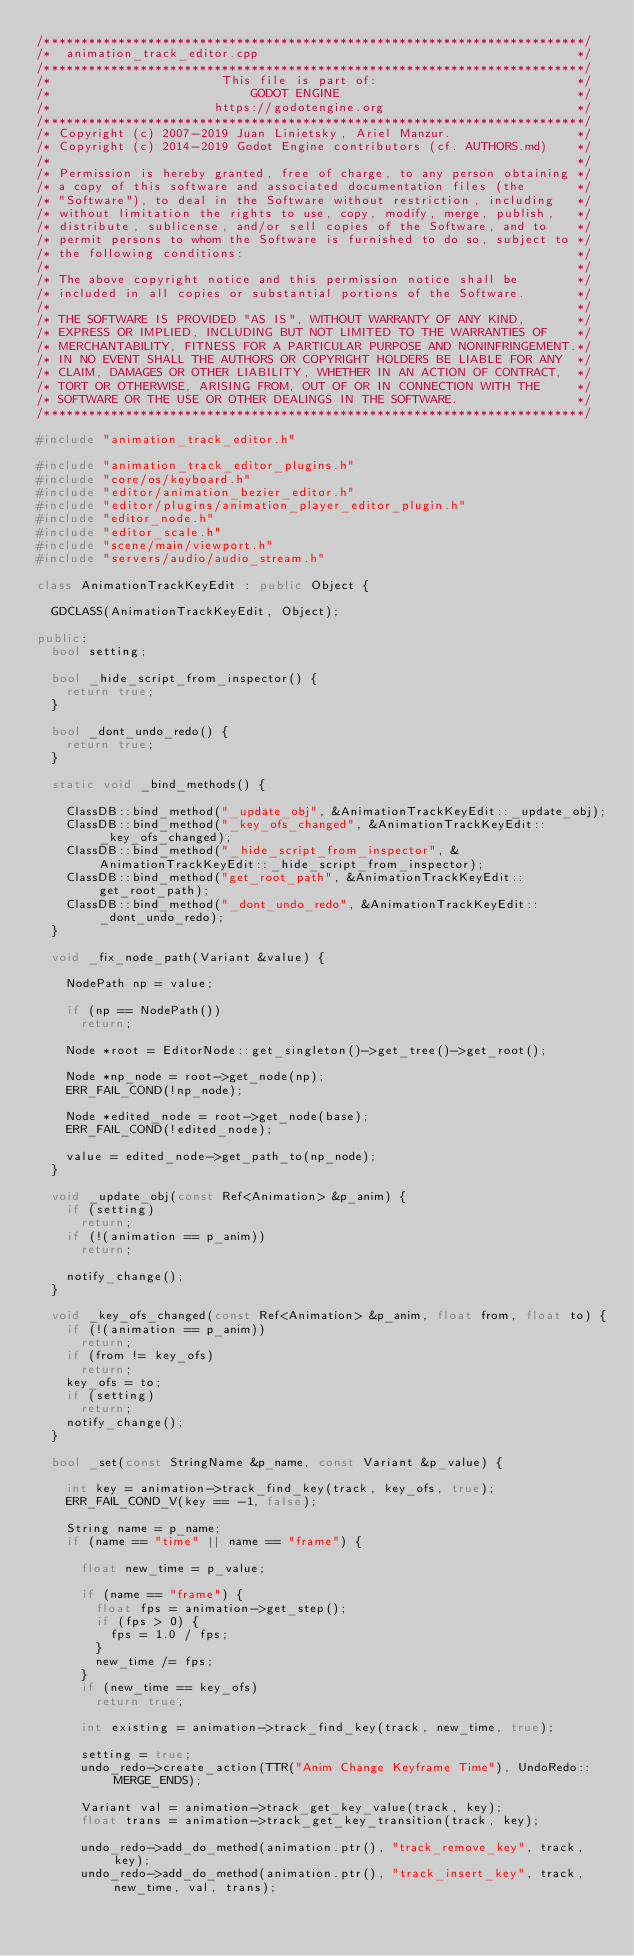Convert code to text. <code><loc_0><loc_0><loc_500><loc_500><_C++_>/*************************************************************************/
/*  animation_track_editor.cpp                                           */
/*************************************************************************/
/*                       This file is part of:                           */
/*                           GODOT ENGINE                                */
/*                      https://godotengine.org                          */
/*************************************************************************/
/* Copyright (c) 2007-2019 Juan Linietsky, Ariel Manzur.                 */
/* Copyright (c) 2014-2019 Godot Engine contributors (cf. AUTHORS.md)    */
/*                                                                       */
/* Permission is hereby granted, free of charge, to any person obtaining */
/* a copy of this software and associated documentation files (the       */
/* "Software"), to deal in the Software without restriction, including   */
/* without limitation the rights to use, copy, modify, merge, publish,   */
/* distribute, sublicense, and/or sell copies of the Software, and to    */
/* permit persons to whom the Software is furnished to do so, subject to */
/* the following conditions:                                             */
/*                                                                       */
/* The above copyright notice and this permission notice shall be        */
/* included in all copies or substantial portions of the Software.       */
/*                                                                       */
/* THE SOFTWARE IS PROVIDED "AS IS", WITHOUT WARRANTY OF ANY KIND,       */
/* EXPRESS OR IMPLIED, INCLUDING BUT NOT LIMITED TO THE WARRANTIES OF    */
/* MERCHANTABILITY, FITNESS FOR A PARTICULAR PURPOSE AND NONINFRINGEMENT.*/
/* IN NO EVENT SHALL THE AUTHORS OR COPYRIGHT HOLDERS BE LIABLE FOR ANY  */
/* CLAIM, DAMAGES OR OTHER LIABILITY, WHETHER IN AN ACTION OF CONTRACT,  */
/* TORT OR OTHERWISE, ARISING FROM, OUT OF OR IN CONNECTION WITH THE     */
/* SOFTWARE OR THE USE OR OTHER DEALINGS IN THE SOFTWARE.                */
/*************************************************************************/

#include "animation_track_editor.h"

#include "animation_track_editor_plugins.h"
#include "core/os/keyboard.h"
#include "editor/animation_bezier_editor.h"
#include "editor/plugins/animation_player_editor_plugin.h"
#include "editor_node.h"
#include "editor_scale.h"
#include "scene/main/viewport.h"
#include "servers/audio/audio_stream.h"

class AnimationTrackKeyEdit : public Object {

	GDCLASS(AnimationTrackKeyEdit, Object);

public:
	bool setting;

	bool _hide_script_from_inspector() {
		return true;
	}

	bool _dont_undo_redo() {
		return true;
	}

	static void _bind_methods() {

		ClassDB::bind_method("_update_obj", &AnimationTrackKeyEdit::_update_obj);
		ClassDB::bind_method("_key_ofs_changed", &AnimationTrackKeyEdit::_key_ofs_changed);
		ClassDB::bind_method("_hide_script_from_inspector", &AnimationTrackKeyEdit::_hide_script_from_inspector);
		ClassDB::bind_method("get_root_path", &AnimationTrackKeyEdit::get_root_path);
		ClassDB::bind_method("_dont_undo_redo", &AnimationTrackKeyEdit::_dont_undo_redo);
	}

	void _fix_node_path(Variant &value) {

		NodePath np = value;

		if (np == NodePath())
			return;

		Node *root = EditorNode::get_singleton()->get_tree()->get_root();

		Node *np_node = root->get_node(np);
		ERR_FAIL_COND(!np_node);

		Node *edited_node = root->get_node(base);
		ERR_FAIL_COND(!edited_node);

		value = edited_node->get_path_to(np_node);
	}

	void _update_obj(const Ref<Animation> &p_anim) {
		if (setting)
			return;
		if (!(animation == p_anim))
			return;

		notify_change();
	}

	void _key_ofs_changed(const Ref<Animation> &p_anim, float from, float to) {
		if (!(animation == p_anim))
			return;
		if (from != key_ofs)
			return;
		key_ofs = to;
		if (setting)
			return;
		notify_change();
	}

	bool _set(const StringName &p_name, const Variant &p_value) {

		int key = animation->track_find_key(track, key_ofs, true);
		ERR_FAIL_COND_V(key == -1, false);

		String name = p_name;
		if (name == "time" || name == "frame") {

			float new_time = p_value;

			if (name == "frame") {
				float fps = animation->get_step();
				if (fps > 0) {
					fps = 1.0 / fps;
				}
				new_time /= fps;
			}
			if (new_time == key_ofs)
				return true;

			int existing = animation->track_find_key(track, new_time, true);

			setting = true;
			undo_redo->create_action(TTR("Anim Change Keyframe Time"), UndoRedo::MERGE_ENDS);

			Variant val = animation->track_get_key_value(track, key);
			float trans = animation->track_get_key_transition(track, key);

			undo_redo->add_do_method(animation.ptr(), "track_remove_key", track, key);
			undo_redo->add_do_method(animation.ptr(), "track_insert_key", track, new_time, val, trans);</code> 